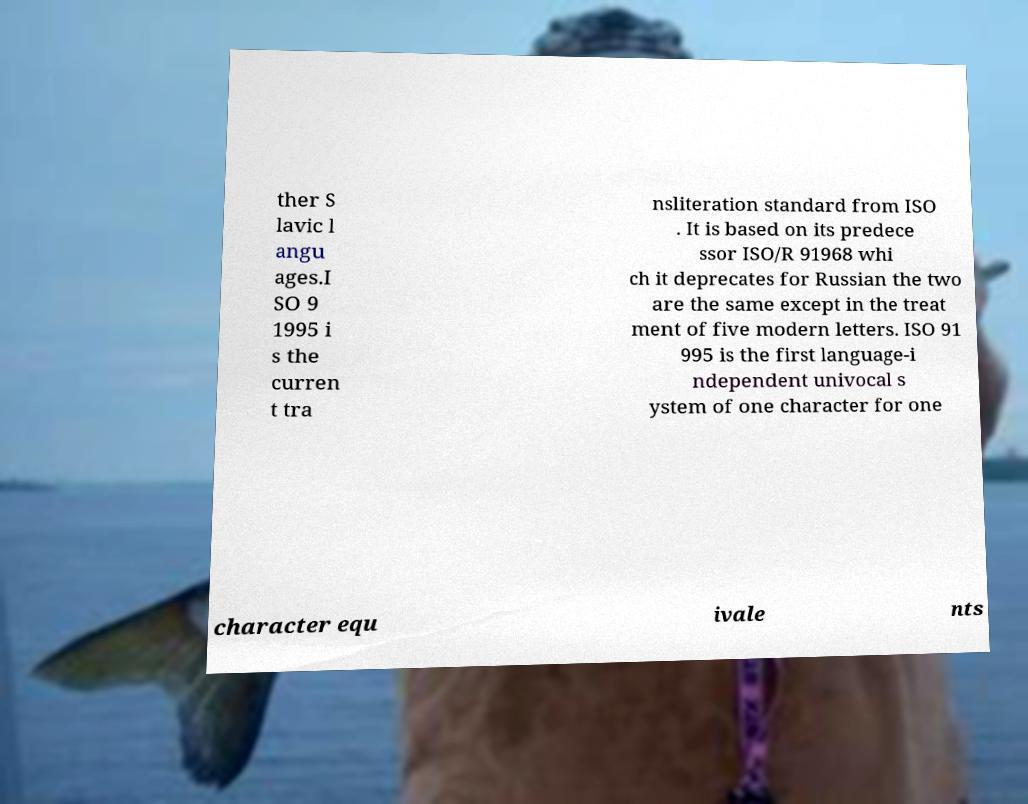Please read and relay the text visible in this image. What does it say? ther S lavic l angu ages.I SO 9 1995 i s the curren t tra nsliteration standard from ISO . It is based on its predece ssor ISO/R 91968 whi ch it deprecates for Russian the two are the same except in the treat ment of five modern letters. ISO 91 995 is the first language-i ndependent univocal s ystem of one character for one character equ ivale nts 